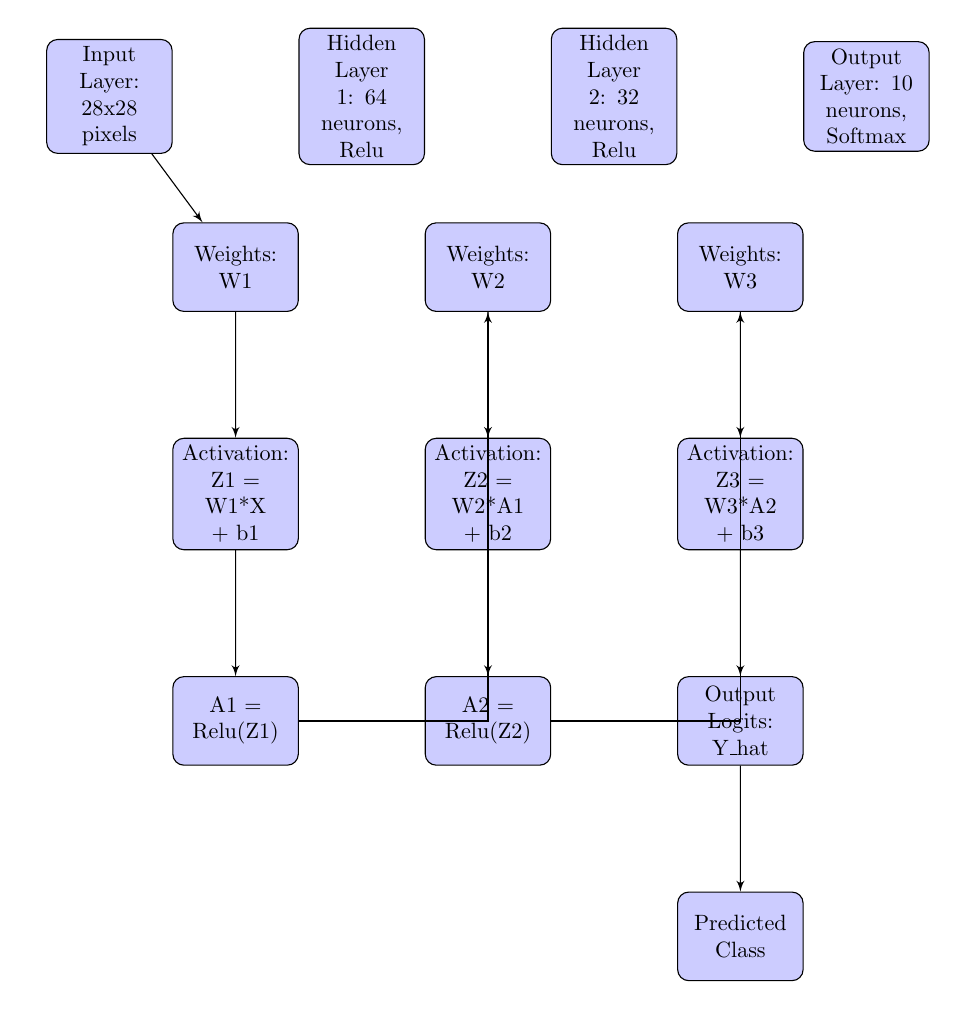What is the size of the input layer? The input layer consists of 28x28 pixels, as indicated in the diagram.
Answer: 28x28 pixels How many neurons are in Hidden Layer 1? The diagram specifies that Hidden Layer 1 contains 64 neurons.
Answer: 64 neurons What activation function is used in Hidden Layer 2? The diagram shows that Hidden Layer 2 uses the ReLU activation function, abbreviated as Relu in the block.
Answer: Relu How many weights are present in the network? There are three weight blocks in the diagram: W1, W2, and W3, which indicates there are three sets of weights.
Answer: 3 What is calculated in the activation step Z3? Z3 is calculated as W3*A2 + b3, where W3 represents weights associated with the final layer, A2 is the output from the previous layer, and b3 is a bias.
Answer: W3*A2 + b3 What is the final output from the network called? The final output from the network is denoted as Y_hat in the diagram, representing output logits.
Answer: Y_hat What happens to the output logits Y_hat? The output logits, Y_hat, flow directly to the Predicted Class block, indicating it is used to determine the class prediction.
Answer: It leads to Predicted Class What does the layer labeled "Hidden Layer 1" output? Hidden Layer 1 outputs A1, the result of applying the ReLU activation function to Z1, which is calculated from the weights W1 and input X.
Answer: A1 = Relu(Z1) How does the diagram connect the input layer to the output layer? The data flows through the sequence of weight calculations (W1, W2, W3), activation functions (Relu), and intermediate outputs (A1, A2) before reaching the output layer, showing a feed-forward neural network structure.
Answer: Through weight and activation layers 